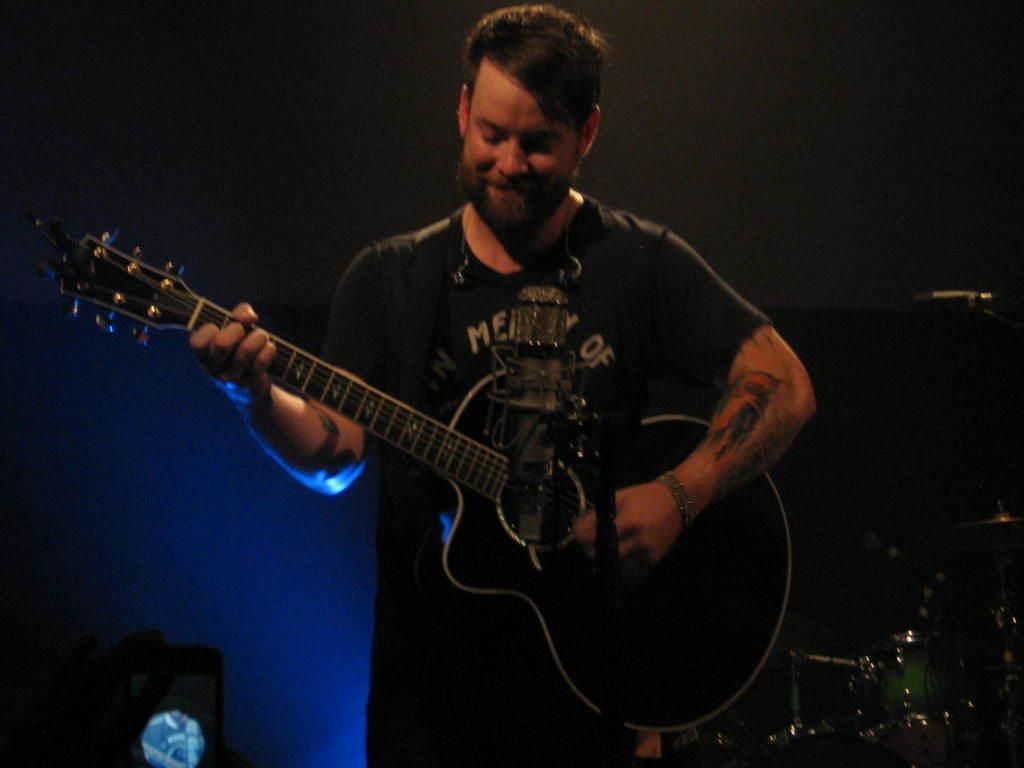What is the main subject of the image? There is a person in the image. What is the person doing in the image? The person is playing a guitar. What position is the person in while playing the guitar? The person is standing. What angle is the person's body at while playing the guitar in the image? There is no specific angle mentioned for the person's body in the image, and it cannot be determined from the provided facts. 